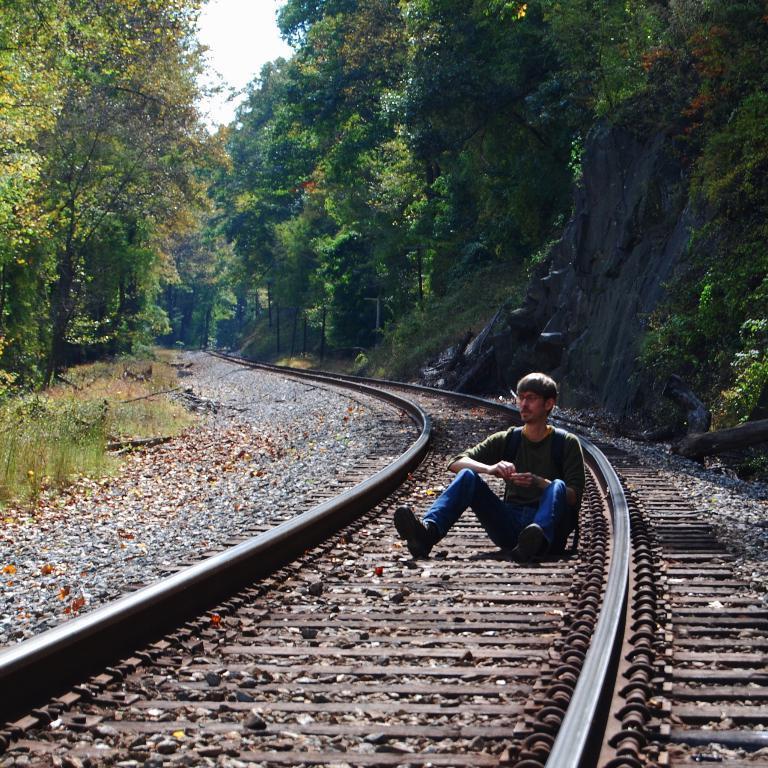In one or two sentences, can you explain what this image depicts? In this image we can see a person sitting on the railway track, there are some trees, grass, rocks and mountains, also we can see the sky. 